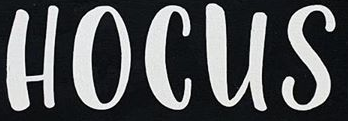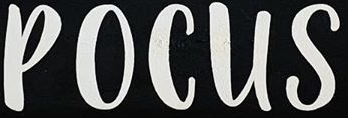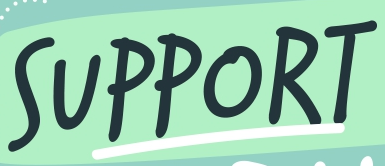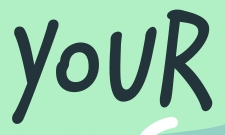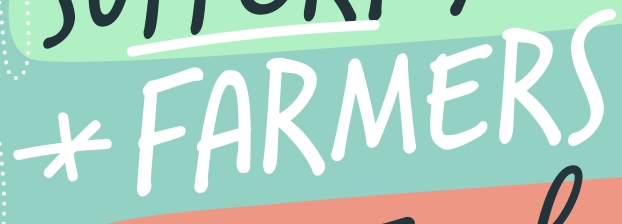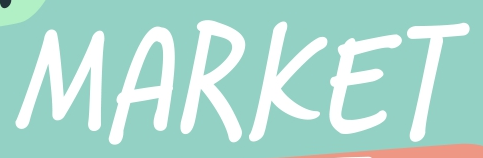What text is displayed in these images sequentially, separated by a semicolon? HOCUS; POCUS; SUPPORT; YOUR; *FARMERS; MARKET 